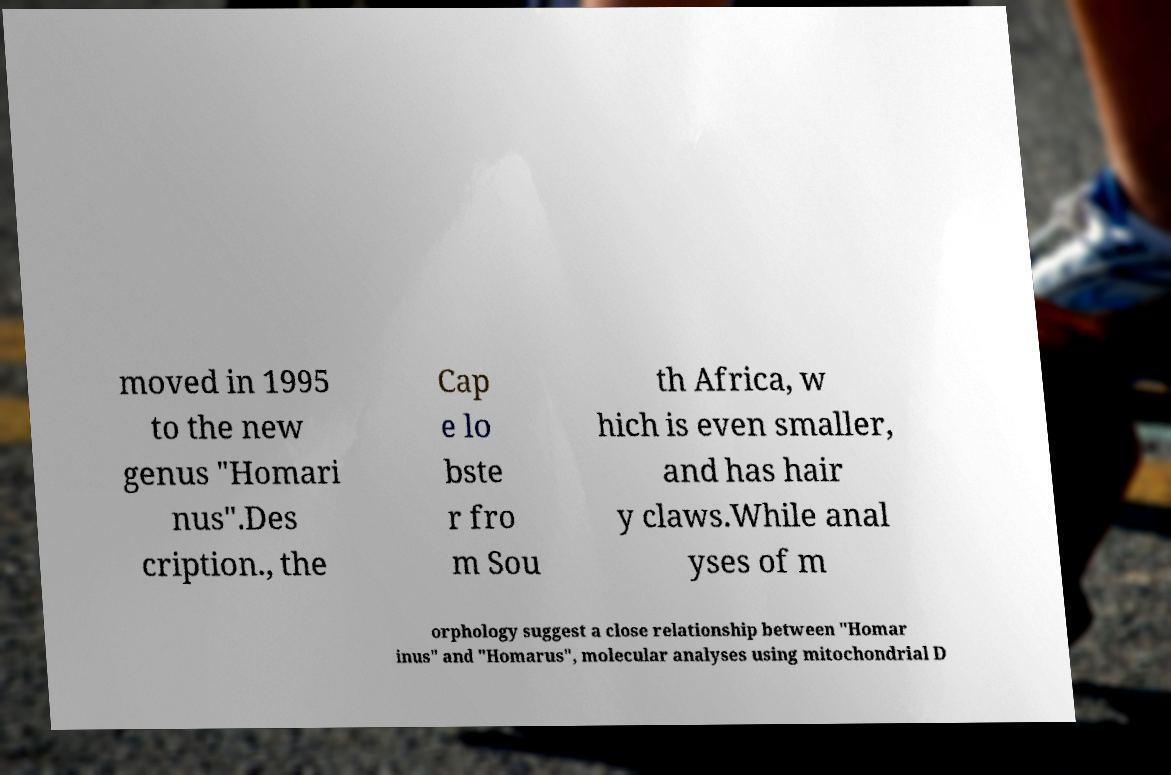There's text embedded in this image that I need extracted. Can you transcribe it verbatim? moved in 1995 to the new genus "Homari nus".Des cription., the Cap e lo bste r fro m Sou th Africa, w hich is even smaller, and has hair y claws.While anal yses of m orphology suggest a close relationship between "Homar inus" and "Homarus", molecular analyses using mitochondrial D 